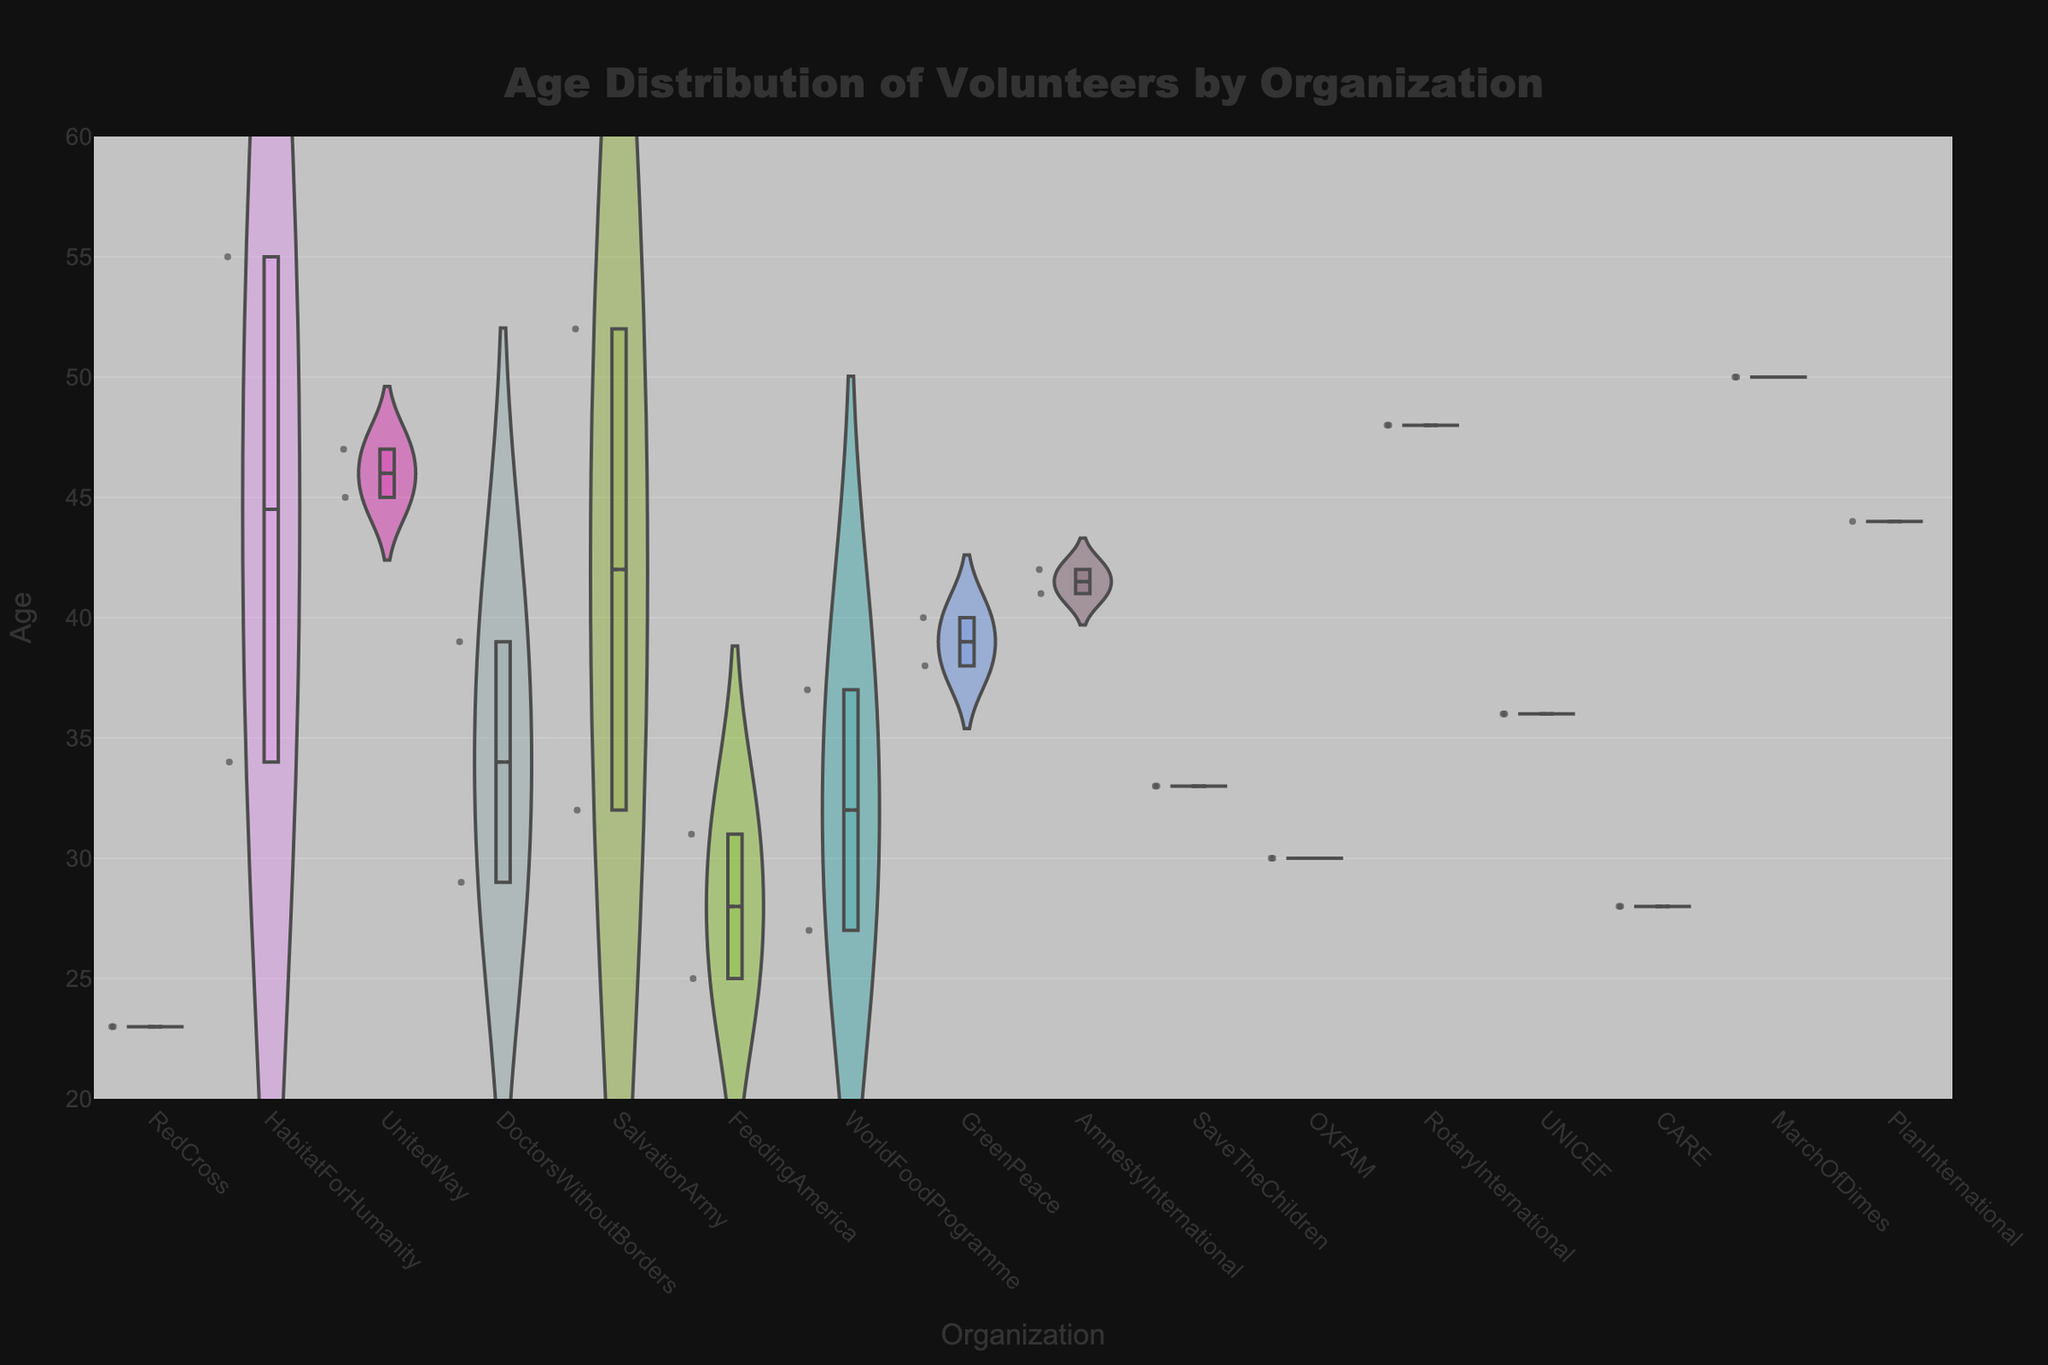What is the title of the figure? The title is usually placed at the top of the figure and it provides a summary of what the chart is about. In this case, it reads: "Age Distribution of Volunteers by Organization".
Answer: "Age Distribution of Volunteers by Organization" What is the range of ages represented on the y-axis? The y-axis range typically spans from the minimum to the maximum value to show the distribution accurately. In this figure, the values range from 20 to 60.
Answer: 20 to 60 Which organization has the widest age distribution of volunteers? To find the organization with the widest age distribution, look for the violin plot that spans the largest range on the y-axis. The organization HabitatForHumanity seems to have volunteers ranging from mid-20s to mid-50s.
Answer: HabitatForHumanity What is the median age of volunteers for the organization UnitedWay? The median is represented by the central line within the box of the box plot overlay. For UnitedWay, the median age is around 45 years old.
Answer: 45 Is there any organization where the volunteers' ages are highly concentrated around the median? An organization with highly concentrated ages will have a violin shape that is narrow and tall, and a small interquartile range in the box plot. FeedingAmerica shows such a distribution with ages mostly around the median of approximately 28-31 years.
Answer: FeedingAmerica Which organizations have their median ages above 40? The median age above 40 can be identified by looking at the central line inside the box plot for each organization. Organizations with median ages above 40 are UnitedWay, GreenPeace, AmnestyInternational, RotaryInternational, and HabitatForHumanity.
Answer: UnitedWay, GreenPeace, AmnestyInternational, RotaryInternational, HabitatForHumanity Compare the age distributions of RedCross and SalvationArmy. Which has the younger median age? By examining the respective box plots, RedCross has a median age around 23, while SalvationArmy has it around 41. Therefore, RedCross has the younger median age.
Answer: RedCross Which organization's volunteers show the most variability in age? Variability can be inferred by the extent of the interquartile range in the box plot. HabitatForHumanity shows the most variability with a wide interquartile range.
Answer: HabitatForHumanity What is the mean age of volunteers for DoctorsWithoutBorders? The mean is indicated by the dashed line within the box plot overlay. For DoctorsWithoutBorders, the mean age appears to be around 34-36 years.
Answer: 34-36 Are there any outliers in the age distribution for the organization CARE? Outliers are typically shown as individual points that fall outside the whiskers of the box plot. For CARE, no outliers are visible.
Answer: No 